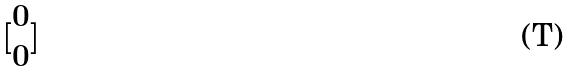Convert formula to latex. <formula><loc_0><loc_0><loc_500><loc_500>[ \begin{matrix} 0 \\ 0 \end{matrix} ]</formula> 